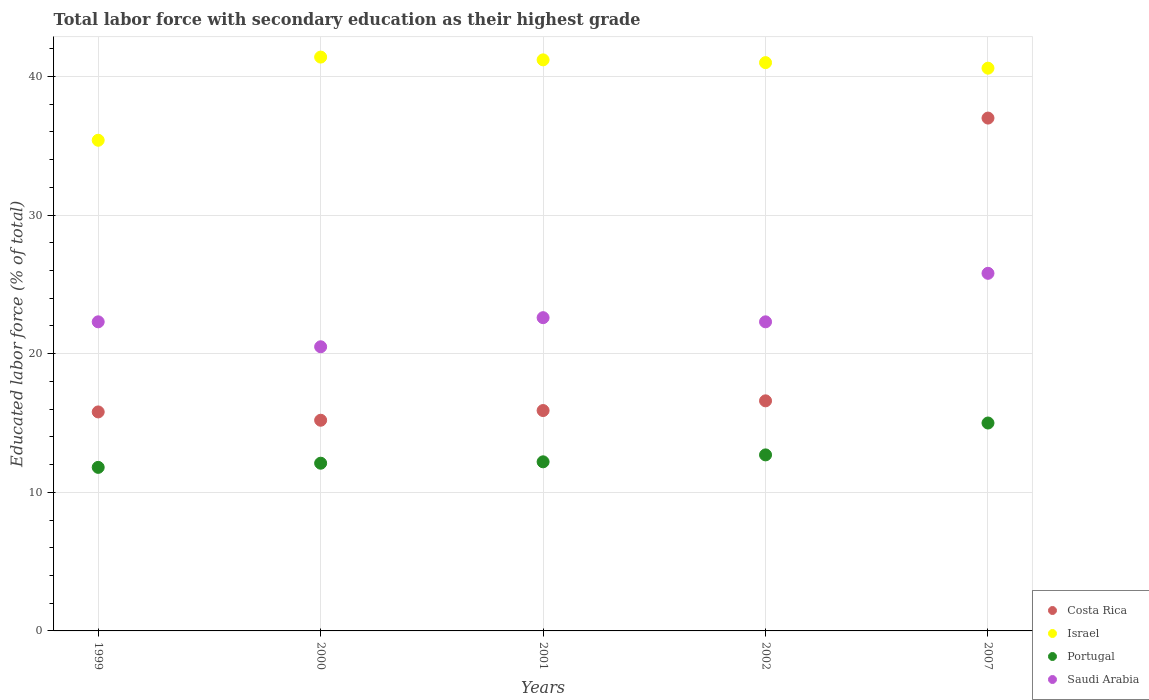What is the percentage of total labor force with primary education in Portugal in 2007?
Keep it short and to the point. 15. Across all years, what is the maximum percentage of total labor force with primary education in Costa Rica?
Your answer should be compact. 37. Across all years, what is the minimum percentage of total labor force with primary education in Portugal?
Your answer should be very brief. 11.8. In which year was the percentage of total labor force with primary education in Portugal maximum?
Offer a very short reply. 2007. In which year was the percentage of total labor force with primary education in Costa Rica minimum?
Provide a succinct answer. 2000. What is the total percentage of total labor force with primary education in Costa Rica in the graph?
Keep it short and to the point. 100.5. What is the difference between the percentage of total labor force with primary education in Israel in 2001 and that in 2007?
Make the answer very short. 0.6. What is the difference between the percentage of total labor force with primary education in Costa Rica in 1999 and the percentage of total labor force with primary education in Israel in 2001?
Keep it short and to the point. -25.4. What is the average percentage of total labor force with primary education in Israel per year?
Offer a very short reply. 39.92. In the year 1999, what is the difference between the percentage of total labor force with primary education in Saudi Arabia and percentage of total labor force with primary education in Portugal?
Provide a short and direct response. 10.5. In how many years, is the percentage of total labor force with primary education in Costa Rica greater than 36 %?
Offer a very short reply. 1. What is the ratio of the percentage of total labor force with primary education in Costa Rica in 1999 to that in 2007?
Your answer should be compact. 0.43. Is the percentage of total labor force with primary education in Israel in 1999 less than that in 2001?
Make the answer very short. Yes. Is the difference between the percentage of total labor force with primary education in Saudi Arabia in 1999 and 2002 greater than the difference between the percentage of total labor force with primary education in Portugal in 1999 and 2002?
Your answer should be compact. Yes. What is the difference between the highest and the second highest percentage of total labor force with primary education in Costa Rica?
Keep it short and to the point. 20.4. What is the difference between the highest and the lowest percentage of total labor force with primary education in Portugal?
Provide a short and direct response. 3.2. Is it the case that in every year, the sum of the percentage of total labor force with primary education in Israel and percentage of total labor force with primary education in Saudi Arabia  is greater than the percentage of total labor force with primary education in Portugal?
Provide a succinct answer. Yes. Is the percentage of total labor force with primary education in Saudi Arabia strictly greater than the percentage of total labor force with primary education in Israel over the years?
Keep it short and to the point. No. How many dotlines are there?
Make the answer very short. 4. How many years are there in the graph?
Keep it short and to the point. 5. Does the graph contain any zero values?
Ensure brevity in your answer.  No. How are the legend labels stacked?
Ensure brevity in your answer.  Vertical. What is the title of the graph?
Provide a short and direct response. Total labor force with secondary education as their highest grade. What is the label or title of the Y-axis?
Offer a very short reply. Educated labor force (% of total). What is the Educated labor force (% of total) in Costa Rica in 1999?
Make the answer very short. 15.8. What is the Educated labor force (% of total) of Israel in 1999?
Give a very brief answer. 35.4. What is the Educated labor force (% of total) in Portugal in 1999?
Your answer should be very brief. 11.8. What is the Educated labor force (% of total) of Saudi Arabia in 1999?
Offer a terse response. 22.3. What is the Educated labor force (% of total) in Costa Rica in 2000?
Your answer should be compact. 15.2. What is the Educated labor force (% of total) in Israel in 2000?
Offer a very short reply. 41.4. What is the Educated labor force (% of total) in Portugal in 2000?
Offer a terse response. 12.1. What is the Educated labor force (% of total) of Costa Rica in 2001?
Ensure brevity in your answer.  15.9. What is the Educated labor force (% of total) of Israel in 2001?
Your answer should be compact. 41.2. What is the Educated labor force (% of total) in Portugal in 2001?
Keep it short and to the point. 12.2. What is the Educated labor force (% of total) in Saudi Arabia in 2001?
Your answer should be compact. 22.6. What is the Educated labor force (% of total) of Costa Rica in 2002?
Your answer should be very brief. 16.6. What is the Educated labor force (% of total) of Portugal in 2002?
Offer a very short reply. 12.7. What is the Educated labor force (% of total) of Saudi Arabia in 2002?
Your answer should be very brief. 22.3. What is the Educated labor force (% of total) in Costa Rica in 2007?
Offer a very short reply. 37. What is the Educated labor force (% of total) of Israel in 2007?
Provide a short and direct response. 40.6. What is the Educated labor force (% of total) in Saudi Arabia in 2007?
Ensure brevity in your answer.  25.8. Across all years, what is the maximum Educated labor force (% of total) in Costa Rica?
Make the answer very short. 37. Across all years, what is the maximum Educated labor force (% of total) of Israel?
Your response must be concise. 41.4. Across all years, what is the maximum Educated labor force (% of total) of Portugal?
Make the answer very short. 15. Across all years, what is the maximum Educated labor force (% of total) in Saudi Arabia?
Provide a short and direct response. 25.8. Across all years, what is the minimum Educated labor force (% of total) in Costa Rica?
Offer a very short reply. 15.2. Across all years, what is the minimum Educated labor force (% of total) of Israel?
Your response must be concise. 35.4. Across all years, what is the minimum Educated labor force (% of total) of Portugal?
Provide a succinct answer. 11.8. Across all years, what is the minimum Educated labor force (% of total) in Saudi Arabia?
Offer a terse response. 20.5. What is the total Educated labor force (% of total) in Costa Rica in the graph?
Your response must be concise. 100.5. What is the total Educated labor force (% of total) in Israel in the graph?
Offer a terse response. 199.6. What is the total Educated labor force (% of total) in Portugal in the graph?
Provide a short and direct response. 63.8. What is the total Educated labor force (% of total) of Saudi Arabia in the graph?
Offer a very short reply. 113.5. What is the difference between the Educated labor force (% of total) of Costa Rica in 1999 and that in 2000?
Your response must be concise. 0.6. What is the difference between the Educated labor force (% of total) in Israel in 1999 and that in 2000?
Provide a succinct answer. -6. What is the difference between the Educated labor force (% of total) of Saudi Arabia in 1999 and that in 2000?
Offer a terse response. 1.8. What is the difference between the Educated labor force (% of total) of Costa Rica in 1999 and that in 2001?
Offer a very short reply. -0.1. What is the difference between the Educated labor force (% of total) in Israel in 1999 and that in 2001?
Your response must be concise. -5.8. What is the difference between the Educated labor force (% of total) in Costa Rica in 1999 and that in 2002?
Ensure brevity in your answer.  -0.8. What is the difference between the Educated labor force (% of total) of Israel in 1999 and that in 2002?
Ensure brevity in your answer.  -5.6. What is the difference between the Educated labor force (% of total) of Saudi Arabia in 1999 and that in 2002?
Provide a short and direct response. 0. What is the difference between the Educated labor force (% of total) in Costa Rica in 1999 and that in 2007?
Offer a very short reply. -21.2. What is the difference between the Educated labor force (% of total) of Portugal in 1999 and that in 2007?
Your response must be concise. -3.2. What is the difference between the Educated labor force (% of total) in Costa Rica in 2000 and that in 2001?
Offer a very short reply. -0.7. What is the difference between the Educated labor force (% of total) of Saudi Arabia in 2000 and that in 2001?
Offer a terse response. -2.1. What is the difference between the Educated labor force (% of total) in Costa Rica in 2000 and that in 2002?
Your answer should be very brief. -1.4. What is the difference between the Educated labor force (% of total) in Saudi Arabia in 2000 and that in 2002?
Offer a very short reply. -1.8. What is the difference between the Educated labor force (% of total) of Costa Rica in 2000 and that in 2007?
Your answer should be very brief. -21.8. What is the difference between the Educated labor force (% of total) in Costa Rica in 2001 and that in 2007?
Ensure brevity in your answer.  -21.1. What is the difference between the Educated labor force (% of total) of Israel in 2001 and that in 2007?
Provide a short and direct response. 0.6. What is the difference between the Educated labor force (% of total) in Saudi Arabia in 2001 and that in 2007?
Make the answer very short. -3.2. What is the difference between the Educated labor force (% of total) of Costa Rica in 2002 and that in 2007?
Offer a terse response. -20.4. What is the difference between the Educated labor force (% of total) in Israel in 2002 and that in 2007?
Your answer should be compact. 0.4. What is the difference between the Educated labor force (% of total) of Costa Rica in 1999 and the Educated labor force (% of total) of Israel in 2000?
Your response must be concise. -25.6. What is the difference between the Educated labor force (% of total) of Israel in 1999 and the Educated labor force (% of total) of Portugal in 2000?
Keep it short and to the point. 23.3. What is the difference between the Educated labor force (% of total) of Portugal in 1999 and the Educated labor force (% of total) of Saudi Arabia in 2000?
Provide a succinct answer. -8.7. What is the difference between the Educated labor force (% of total) of Costa Rica in 1999 and the Educated labor force (% of total) of Israel in 2001?
Your answer should be very brief. -25.4. What is the difference between the Educated labor force (% of total) in Costa Rica in 1999 and the Educated labor force (% of total) in Saudi Arabia in 2001?
Keep it short and to the point. -6.8. What is the difference between the Educated labor force (% of total) of Israel in 1999 and the Educated labor force (% of total) of Portugal in 2001?
Your answer should be very brief. 23.2. What is the difference between the Educated labor force (% of total) in Israel in 1999 and the Educated labor force (% of total) in Saudi Arabia in 2001?
Offer a terse response. 12.8. What is the difference between the Educated labor force (% of total) in Costa Rica in 1999 and the Educated labor force (% of total) in Israel in 2002?
Your answer should be very brief. -25.2. What is the difference between the Educated labor force (% of total) in Israel in 1999 and the Educated labor force (% of total) in Portugal in 2002?
Give a very brief answer. 22.7. What is the difference between the Educated labor force (% of total) of Costa Rica in 1999 and the Educated labor force (% of total) of Israel in 2007?
Give a very brief answer. -24.8. What is the difference between the Educated labor force (% of total) of Costa Rica in 1999 and the Educated labor force (% of total) of Portugal in 2007?
Give a very brief answer. 0.8. What is the difference between the Educated labor force (% of total) in Costa Rica in 1999 and the Educated labor force (% of total) in Saudi Arabia in 2007?
Make the answer very short. -10. What is the difference between the Educated labor force (% of total) of Israel in 1999 and the Educated labor force (% of total) of Portugal in 2007?
Provide a short and direct response. 20.4. What is the difference between the Educated labor force (% of total) of Israel in 1999 and the Educated labor force (% of total) of Saudi Arabia in 2007?
Provide a short and direct response. 9.6. What is the difference between the Educated labor force (% of total) of Portugal in 1999 and the Educated labor force (% of total) of Saudi Arabia in 2007?
Make the answer very short. -14. What is the difference between the Educated labor force (% of total) of Costa Rica in 2000 and the Educated labor force (% of total) of Israel in 2001?
Your answer should be very brief. -26. What is the difference between the Educated labor force (% of total) of Costa Rica in 2000 and the Educated labor force (% of total) of Saudi Arabia in 2001?
Offer a very short reply. -7.4. What is the difference between the Educated labor force (% of total) in Israel in 2000 and the Educated labor force (% of total) in Portugal in 2001?
Offer a very short reply. 29.2. What is the difference between the Educated labor force (% of total) in Portugal in 2000 and the Educated labor force (% of total) in Saudi Arabia in 2001?
Make the answer very short. -10.5. What is the difference between the Educated labor force (% of total) in Costa Rica in 2000 and the Educated labor force (% of total) in Israel in 2002?
Make the answer very short. -25.8. What is the difference between the Educated labor force (% of total) in Costa Rica in 2000 and the Educated labor force (% of total) in Saudi Arabia in 2002?
Your answer should be compact. -7.1. What is the difference between the Educated labor force (% of total) of Israel in 2000 and the Educated labor force (% of total) of Portugal in 2002?
Your answer should be compact. 28.7. What is the difference between the Educated labor force (% of total) in Costa Rica in 2000 and the Educated labor force (% of total) in Israel in 2007?
Provide a short and direct response. -25.4. What is the difference between the Educated labor force (% of total) of Costa Rica in 2000 and the Educated labor force (% of total) of Portugal in 2007?
Your response must be concise. 0.2. What is the difference between the Educated labor force (% of total) in Costa Rica in 2000 and the Educated labor force (% of total) in Saudi Arabia in 2007?
Ensure brevity in your answer.  -10.6. What is the difference between the Educated labor force (% of total) of Israel in 2000 and the Educated labor force (% of total) of Portugal in 2007?
Give a very brief answer. 26.4. What is the difference between the Educated labor force (% of total) of Israel in 2000 and the Educated labor force (% of total) of Saudi Arabia in 2007?
Your answer should be very brief. 15.6. What is the difference between the Educated labor force (% of total) of Portugal in 2000 and the Educated labor force (% of total) of Saudi Arabia in 2007?
Give a very brief answer. -13.7. What is the difference between the Educated labor force (% of total) in Costa Rica in 2001 and the Educated labor force (% of total) in Israel in 2002?
Make the answer very short. -25.1. What is the difference between the Educated labor force (% of total) of Israel in 2001 and the Educated labor force (% of total) of Saudi Arabia in 2002?
Offer a very short reply. 18.9. What is the difference between the Educated labor force (% of total) in Portugal in 2001 and the Educated labor force (% of total) in Saudi Arabia in 2002?
Provide a short and direct response. -10.1. What is the difference between the Educated labor force (% of total) in Costa Rica in 2001 and the Educated labor force (% of total) in Israel in 2007?
Ensure brevity in your answer.  -24.7. What is the difference between the Educated labor force (% of total) of Israel in 2001 and the Educated labor force (% of total) of Portugal in 2007?
Ensure brevity in your answer.  26.2. What is the difference between the Educated labor force (% of total) of Costa Rica in 2002 and the Educated labor force (% of total) of Israel in 2007?
Your response must be concise. -24. What is the difference between the Educated labor force (% of total) of Costa Rica in 2002 and the Educated labor force (% of total) of Portugal in 2007?
Your response must be concise. 1.6. What is the difference between the Educated labor force (% of total) of Israel in 2002 and the Educated labor force (% of total) of Portugal in 2007?
Provide a short and direct response. 26. What is the difference between the Educated labor force (% of total) of Portugal in 2002 and the Educated labor force (% of total) of Saudi Arabia in 2007?
Make the answer very short. -13.1. What is the average Educated labor force (% of total) in Costa Rica per year?
Your response must be concise. 20.1. What is the average Educated labor force (% of total) of Israel per year?
Keep it short and to the point. 39.92. What is the average Educated labor force (% of total) of Portugal per year?
Offer a very short reply. 12.76. What is the average Educated labor force (% of total) in Saudi Arabia per year?
Your response must be concise. 22.7. In the year 1999, what is the difference between the Educated labor force (% of total) in Costa Rica and Educated labor force (% of total) in Israel?
Offer a terse response. -19.6. In the year 1999, what is the difference between the Educated labor force (% of total) of Costa Rica and Educated labor force (% of total) of Portugal?
Keep it short and to the point. 4. In the year 1999, what is the difference between the Educated labor force (% of total) of Israel and Educated labor force (% of total) of Portugal?
Ensure brevity in your answer.  23.6. In the year 1999, what is the difference between the Educated labor force (% of total) in Portugal and Educated labor force (% of total) in Saudi Arabia?
Offer a very short reply. -10.5. In the year 2000, what is the difference between the Educated labor force (% of total) in Costa Rica and Educated labor force (% of total) in Israel?
Your answer should be compact. -26.2. In the year 2000, what is the difference between the Educated labor force (% of total) of Costa Rica and Educated labor force (% of total) of Portugal?
Offer a terse response. 3.1. In the year 2000, what is the difference between the Educated labor force (% of total) in Israel and Educated labor force (% of total) in Portugal?
Ensure brevity in your answer.  29.3. In the year 2000, what is the difference between the Educated labor force (% of total) of Israel and Educated labor force (% of total) of Saudi Arabia?
Give a very brief answer. 20.9. In the year 2000, what is the difference between the Educated labor force (% of total) of Portugal and Educated labor force (% of total) of Saudi Arabia?
Ensure brevity in your answer.  -8.4. In the year 2001, what is the difference between the Educated labor force (% of total) in Costa Rica and Educated labor force (% of total) in Israel?
Make the answer very short. -25.3. In the year 2002, what is the difference between the Educated labor force (% of total) in Costa Rica and Educated labor force (% of total) in Israel?
Offer a terse response. -24.4. In the year 2002, what is the difference between the Educated labor force (% of total) in Costa Rica and Educated labor force (% of total) in Portugal?
Keep it short and to the point. 3.9. In the year 2002, what is the difference between the Educated labor force (% of total) in Israel and Educated labor force (% of total) in Portugal?
Offer a very short reply. 28.3. In the year 2002, what is the difference between the Educated labor force (% of total) of Portugal and Educated labor force (% of total) of Saudi Arabia?
Offer a very short reply. -9.6. In the year 2007, what is the difference between the Educated labor force (% of total) in Costa Rica and Educated labor force (% of total) in Israel?
Provide a succinct answer. -3.6. In the year 2007, what is the difference between the Educated labor force (% of total) in Costa Rica and Educated labor force (% of total) in Portugal?
Your answer should be compact. 22. In the year 2007, what is the difference between the Educated labor force (% of total) in Costa Rica and Educated labor force (% of total) in Saudi Arabia?
Your response must be concise. 11.2. In the year 2007, what is the difference between the Educated labor force (% of total) in Israel and Educated labor force (% of total) in Portugal?
Offer a terse response. 25.6. In the year 2007, what is the difference between the Educated labor force (% of total) of Israel and Educated labor force (% of total) of Saudi Arabia?
Your response must be concise. 14.8. In the year 2007, what is the difference between the Educated labor force (% of total) in Portugal and Educated labor force (% of total) in Saudi Arabia?
Offer a terse response. -10.8. What is the ratio of the Educated labor force (% of total) in Costa Rica in 1999 to that in 2000?
Ensure brevity in your answer.  1.04. What is the ratio of the Educated labor force (% of total) in Israel in 1999 to that in 2000?
Provide a short and direct response. 0.86. What is the ratio of the Educated labor force (% of total) in Portugal in 1999 to that in 2000?
Ensure brevity in your answer.  0.98. What is the ratio of the Educated labor force (% of total) of Saudi Arabia in 1999 to that in 2000?
Keep it short and to the point. 1.09. What is the ratio of the Educated labor force (% of total) in Costa Rica in 1999 to that in 2001?
Offer a very short reply. 0.99. What is the ratio of the Educated labor force (% of total) in Israel in 1999 to that in 2001?
Keep it short and to the point. 0.86. What is the ratio of the Educated labor force (% of total) of Portugal in 1999 to that in 2001?
Offer a very short reply. 0.97. What is the ratio of the Educated labor force (% of total) in Saudi Arabia in 1999 to that in 2001?
Keep it short and to the point. 0.99. What is the ratio of the Educated labor force (% of total) in Costa Rica in 1999 to that in 2002?
Offer a very short reply. 0.95. What is the ratio of the Educated labor force (% of total) in Israel in 1999 to that in 2002?
Your response must be concise. 0.86. What is the ratio of the Educated labor force (% of total) in Portugal in 1999 to that in 2002?
Make the answer very short. 0.93. What is the ratio of the Educated labor force (% of total) in Saudi Arabia in 1999 to that in 2002?
Ensure brevity in your answer.  1. What is the ratio of the Educated labor force (% of total) of Costa Rica in 1999 to that in 2007?
Offer a terse response. 0.43. What is the ratio of the Educated labor force (% of total) in Israel in 1999 to that in 2007?
Provide a succinct answer. 0.87. What is the ratio of the Educated labor force (% of total) of Portugal in 1999 to that in 2007?
Offer a very short reply. 0.79. What is the ratio of the Educated labor force (% of total) of Saudi Arabia in 1999 to that in 2007?
Provide a short and direct response. 0.86. What is the ratio of the Educated labor force (% of total) of Costa Rica in 2000 to that in 2001?
Keep it short and to the point. 0.96. What is the ratio of the Educated labor force (% of total) of Israel in 2000 to that in 2001?
Give a very brief answer. 1. What is the ratio of the Educated labor force (% of total) of Portugal in 2000 to that in 2001?
Your answer should be compact. 0.99. What is the ratio of the Educated labor force (% of total) of Saudi Arabia in 2000 to that in 2001?
Offer a very short reply. 0.91. What is the ratio of the Educated labor force (% of total) of Costa Rica in 2000 to that in 2002?
Offer a very short reply. 0.92. What is the ratio of the Educated labor force (% of total) in Israel in 2000 to that in 2002?
Your response must be concise. 1.01. What is the ratio of the Educated labor force (% of total) in Portugal in 2000 to that in 2002?
Your answer should be very brief. 0.95. What is the ratio of the Educated labor force (% of total) of Saudi Arabia in 2000 to that in 2002?
Your answer should be compact. 0.92. What is the ratio of the Educated labor force (% of total) of Costa Rica in 2000 to that in 2007?
Your answer should be very brief. 0.41. What is the ratio of the Educated labor force (% of total) in Israel in 2000 to that in 2007?
Your response must be concise. 1.02. What is the ratio of the Educated labor force (% of total) in Portugal in 2000 to that in 2007?
Keep it short and to the point. 0.81. What is the ratio of the Educated labor force (% of total) in Saudi Arabia in 2000 to that in 2007?
Provide a succinct answer. 0.79. What is the ratio of the Educated labor force (% of total) in Costa Rica in 2001 to that in 2002?
Keep it short and to the point. 0.96. What is the ratio of the Educated labor force (% of total) of Portugal in 2001 to that in 2002?
Ensure brevity in your answer.  0.96. What is the ratio of the Educated labor force (% of total) in Saudi Arabia in 2001 to that in 2002?
Make the answer very short. 1.01. What is the ratio of the Educated labor force (% of total) in Costa Rica in 2001 to that in 2007?
Provide a short and direct response. 0.43. What is the ratio of the Educated labor force (% of total) in Israel in 2001 to that in 2007?
Offer a very short reply. 1.01. What is the ratio of the Educated labor force (% of total) of Portugal in 2001 to that in 2007?
Your answer should be very brief. 0.81. What is the ratio of the Educated labor force (% of total) in Saudi Arabia in 2001 to that in 2007?
Keep it short and to the point. 0.88. What is the ratio of the Educated labor force (% of total) of Costa Rica in 2002 to that in 2007?
Your answer should be very brief. 0.45. What is the ratio of the Educated labor force (% of total) in Israel in 2002 to that in 2007?
Keep it short and to the point. 1.01. What is the ratio of the Educated labor force (% of total) of Portugal in 2002 to that in 2007?
Keep it short and to the point. 0.85. What is the ratio of the Educated labor force (% of total) of Saudi Arabia in 2002 to that in 2007?
Give a very brief answer. 0.86. What is the difference between the highest and the second highest Educated labor force (% of total) of Costa Rica?
Offer a terse response. 20.4. What is the difference between the highest and the second highest Educated labor force (% of total) in Israel?
Make the answer very short. 0.2. What is the difference between the highest and the lowest Educated labor force (% of total) in Costa Rica?
Your answer should be very brief. 21.8. What is the difference between the highest and the lowest Educated labor force (% of total) in Portugal?
Your response must be concise. 3.2. What is the difference between the highest and the lowest Educated labor force (% of total) of Saudi Arabia?
Provide a short and direct response. 5.3. 